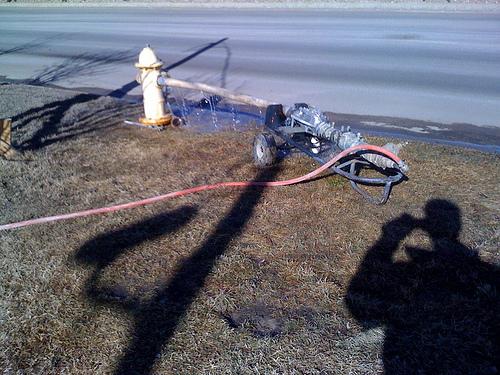What does the shadow reveal?
Short answer required. Man. What is connected to the fire hydrant?
Answer briefly. Hose. What is the yellow thing?
Short answer required. Fire hydrant. 